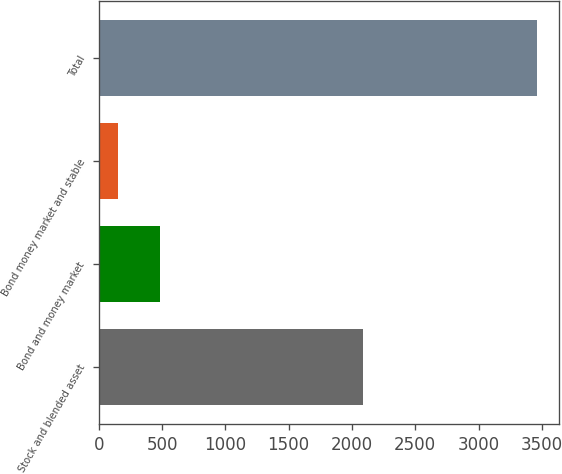<chart> <loc_0><loc_0><loc_500><loc_500><bar_chart><fcel>Stock and blended asset<fcel>Bond and money market<fcel>Bond money market and stable<fcel>Total<nl><fcel>2086<fcel>485.23<fcel>154.2<fcel>3464.5<nl></chart> 